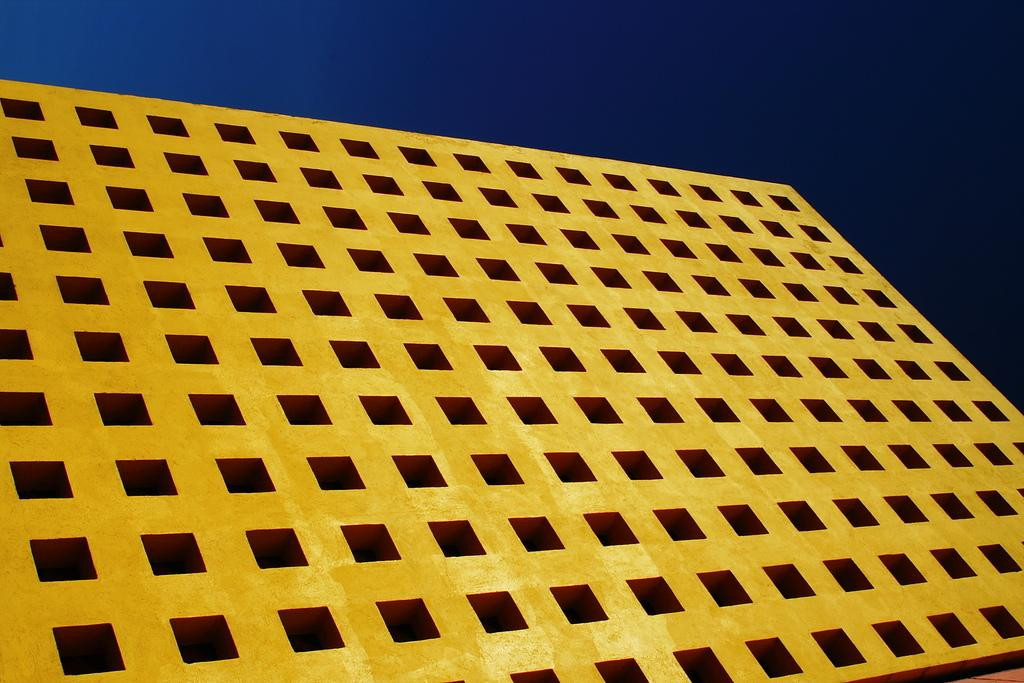What is the main subject in the center of the image? There is a building in the center of the image. What can be seen in the background of the image? The sky is visible in the background of the image. How many bits are attached to the cable in the image? There is no cable or bit present in the image. What is the hand doing in the image? There is no hand present in the image. 